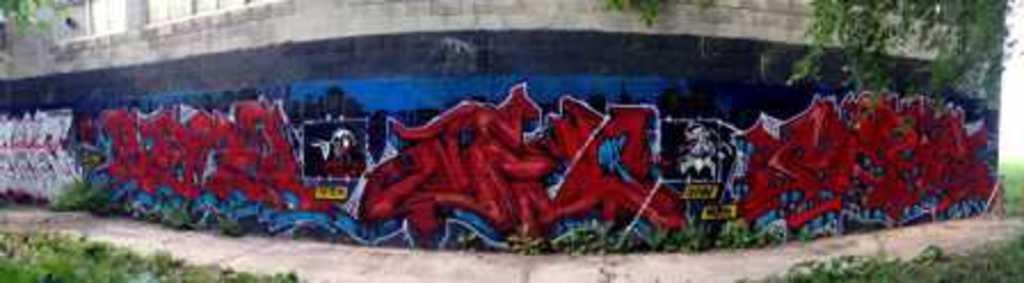What is the main subject in the center of the image? There is a wall in the center of the image. What can be seen on the wall? The wall has graffiti on it. What type of flowers can be seen growing on the branch in the image? There are no flowers or branches present in the image; it only features a wall with graffiti. 